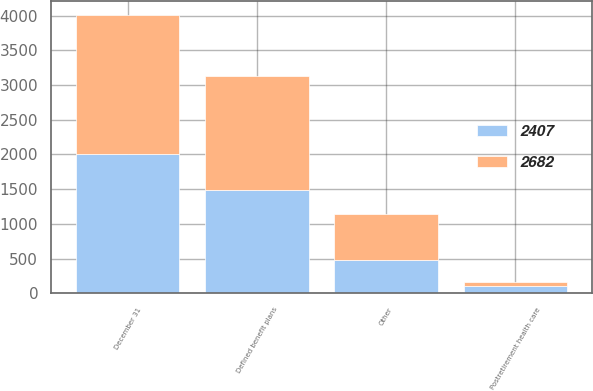<chart> <loc_0><loc_0><loc_500><loc_500><stacked_bar_chart><ecel><fcel>December 31<fcel>Defined benefit plans<fcel>Postretirement health care<fcel>Other<nl><fcel>2682<fcel>2005<fcel>1644<fcel>66<fcel>657<nl><fcel>2407<fcel>2004<fcel>1481<fcel>100<fcel>486<nl></chart> 